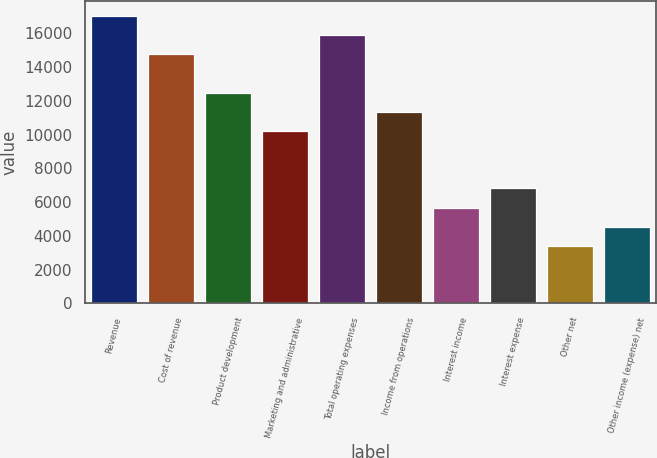Convert chart to OTSL. <chart><loc_0><loc_0><loc_500><loc_500><bar_chart><fcel>Revenue<fcel>Cost of revenue<fcel>Product development<fcel>Marketing and administrative<fcel>Total operating expenses<fcel>Income from operations<fcel>Interest income<fcel>Interest expense<fcel>Other net<fcel>Other income (expense) net<nl><fcel>17039.8<fcel>14767.9<fcel>12495.9<fcel>10224<fcel>15903.8<fcel>11360<fcel>5680.18<fcel>6816.14<fcel>3408.26<fcel>4544.22<nl></chart> 